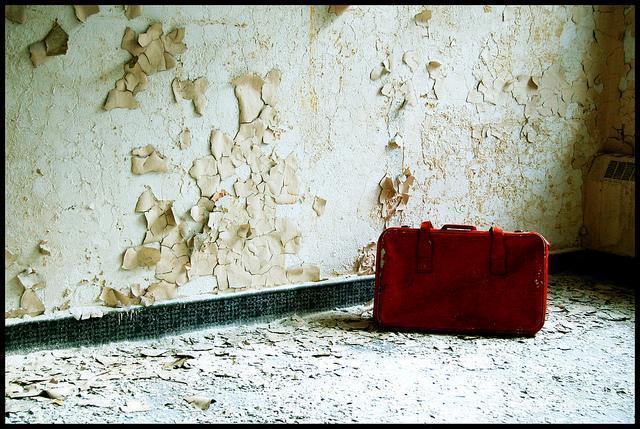How many buses are in this picture?
Give a very brief answer. 0. 